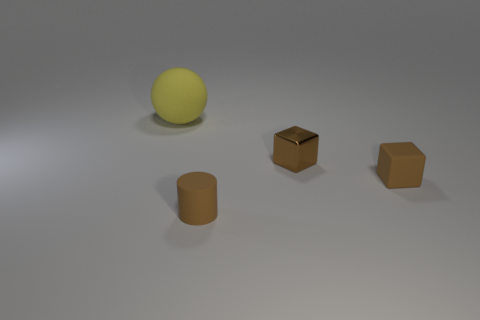Add 4 tiny blue metal cubes. How many objects exist? 8 Subtract all cylinders. How many objects are left? 3 Add 3 brown rubber blocks. How many brown rubber blocks exist? 4 Subtract 0 brown spheres. How many objects are left? 4 Subtract all yellow balls. Subtract all brown matte cylinders. How many objects are left? 2 Add 1 large matte things. How many large matte things are left? 2 